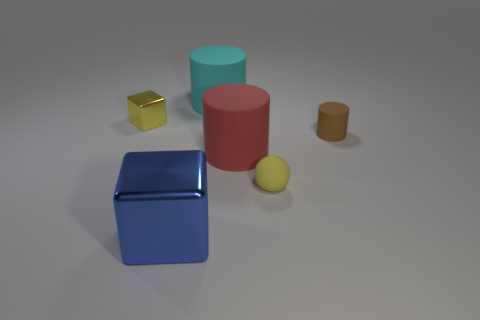Is there anything else that is the same color as the big shiny cube? There are no other objects in the image that share the exact color and shine of the large blue cube. The cube is unique in its appearance among the group of objects presented. 